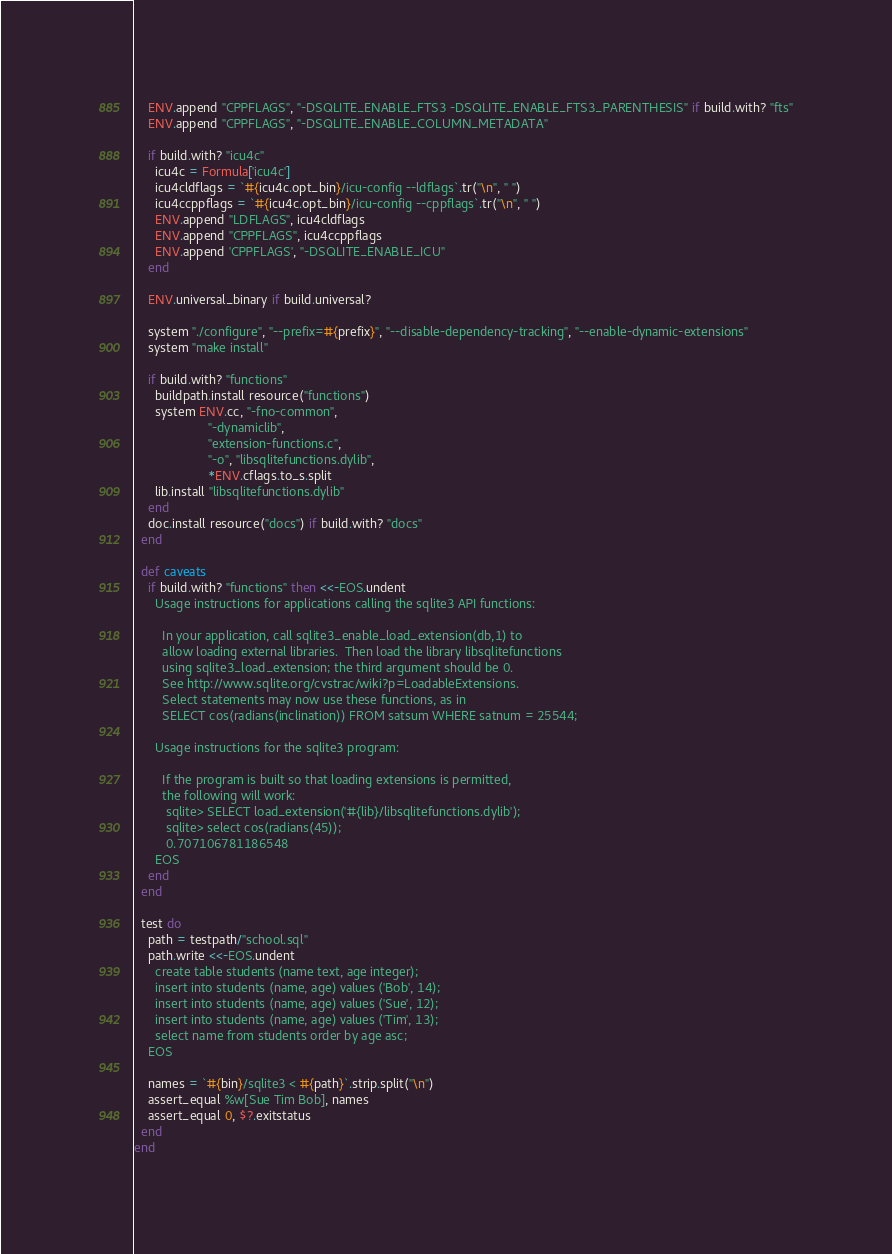Convert code to text. <code><loc_0><loc_0><loc_500><loc_500><_Ruby_>    ENV.append "CPPFLAGS", "-DSQLITE_ENABLE_FTS3 -DSQLITE_ENABLE_FTS3_PARENTHESIS" if build.with? "fts"
    ENV.append "CPPFLAGS", "-DSQLITE_ENABLE_COLUMN_METADATA"

    if build.with? "icu4c"
      icu4c = Formula['icu4c']
      icu4cldflags = `#{icu4c.opt_bin}/icu-config --ldflags`.tr("\n", " ")
      icu4ccppflags = `#{icu4c.opt_bin}/icu-config --cppflags`.tr("\n", " ")
      ENV.append "LDFLAGS", icu4cldflags
      ENV.append "CPPFLAGS", icu4ccppflags
      ENV.append 'CPPFLAGS', "-DSQLITE_ENABLE_ICU"
    end

    ENV.universal_binary if build.universal?

    system "./configure", "--prefix=#{prefix}", "--disable-dependency-tracking", "--enable-dynamic-extensions"
    system "make install"

    if build.with? "functions"
      buildpath.install resource("functions")
      system ENV.cc, "-fno-common",
                     "-dynamiclib",
                     "extension-functions.c",
                     "-o", "libsqlitefunctions.dylib",
                     *ENV.cflags.to_s.split
      lib.install "libsqlitefunctions.dylib"
    end
    doc.install resource("docs") if build.with? "docs"
  end

  def caveats
    if build.with? "functions" then <<-EOS.undent
      Usage instructions for applications calling the sqlite3 API functions:

        In your application, call sqlite3_enable_load_extension(db,1) to
        allow loading external libraries.  Then load the library libsqlitefunctions
        using sqlite3_load_extension; the third argument should be 0.
        See http://www.sqlite.org/cvstrac/wiki?p=LoadableExtensions.
        Select statements may now use these functions, as in
        SELECT cos(radians(inclination)) FROM satsum WHERE satnum = 25544;

      Usage instructions for the sqlite3 program:

        If the program is built so that loading extensions is permitted,
        the following will work:
         sqlite> SELECT load_extension('#{lib}/libsqlitefunctions.dylib');
         sqlite> select cos(radians(45));
         0.707106781186548
      EOS
    end
  end

  test do
    path = testpath/"school.sql"
    path.write <<-EOS.undent
      create table students (name text, age integer);
      insert into students (name, age) values ('Bob', 14);
      insert into students (name, age) values ('Sue', 12);
      insert into students (name, age) values ('Tim', 13);
      select name from students order by age asc;
    EOS

    names = `#{bin}/sqlite3 < #{path}`.strip.split("\n")
    assert_equal %w[Sue Tim Bob], names
    assert_equal 0, $?.exitstatus
  end
end
</code> 